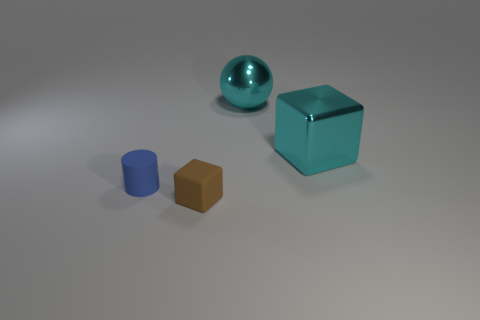There is a big ball that is the same material as the big cyan cube; what color is it? The big ball shares the same reflective, glossy finish as the big cyan cube, indicating that they are made from similar materials. Given that they share these material properties, the color of the big ball is cyan as well. 